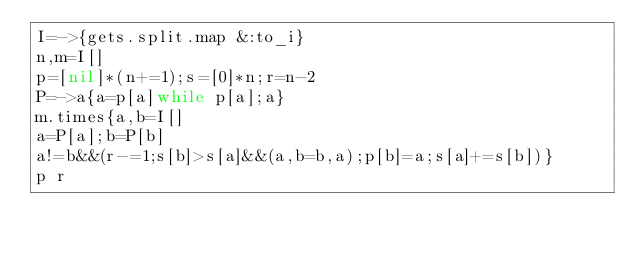<code> <loc_0><loc_0><loc_500><loc_500><_Ruby_>I=->{gets.split.map &:to_i}
n,m=I[]
p=[nil]*(n+=1);s=[0]*n;r=n-2
P=->a{a=p[a]while p[a];a}
m.times{a,b=I[]
a=P[a];b=P[b]
a!=b&&(r-=1;s[b]>s[a]&&(a,b=b,a);p[b]=a;s[a]+=s[b])}
p r
</code> 